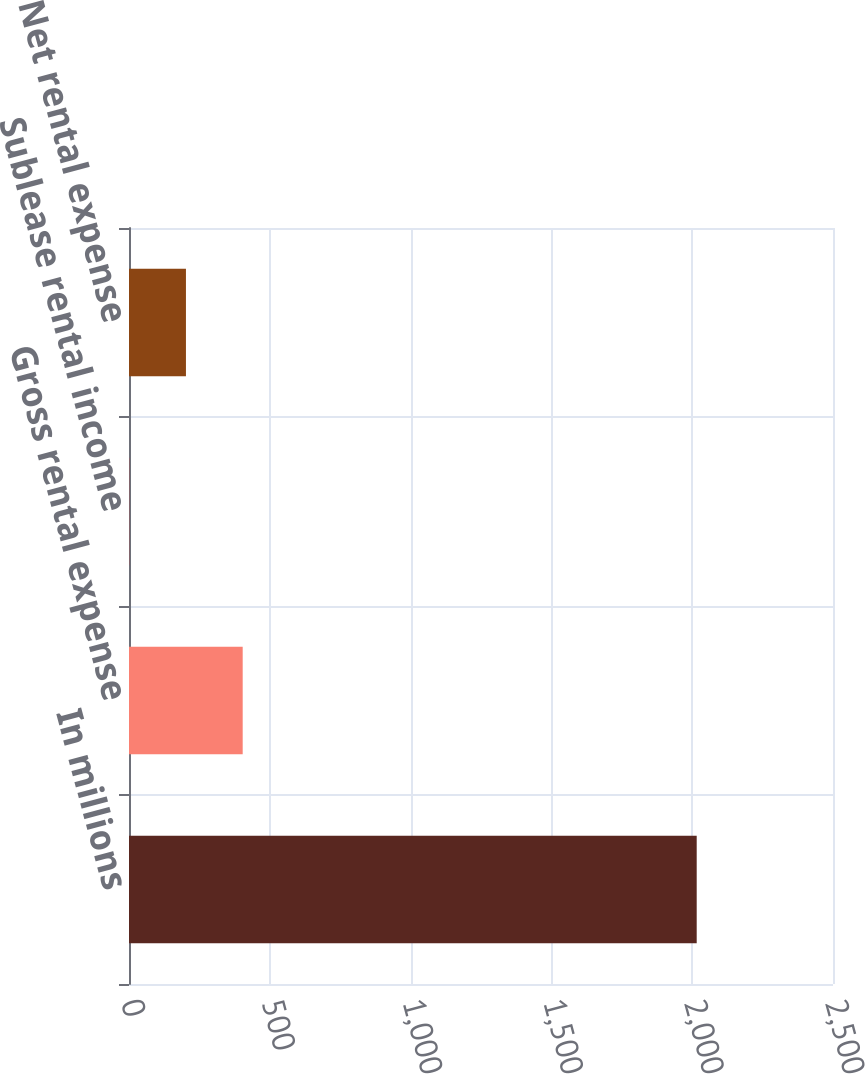<chart> <loc_0><loc_0><loc_500><loc_500><bar_chart><fcel>In millions<fcel>Gross rental expense<fcel>Sublease rental income<fcel>Net rental expense<nl><fcel>2016<fcel>403.76<fcel>0.7<fcel>202.23<nl></chart> 